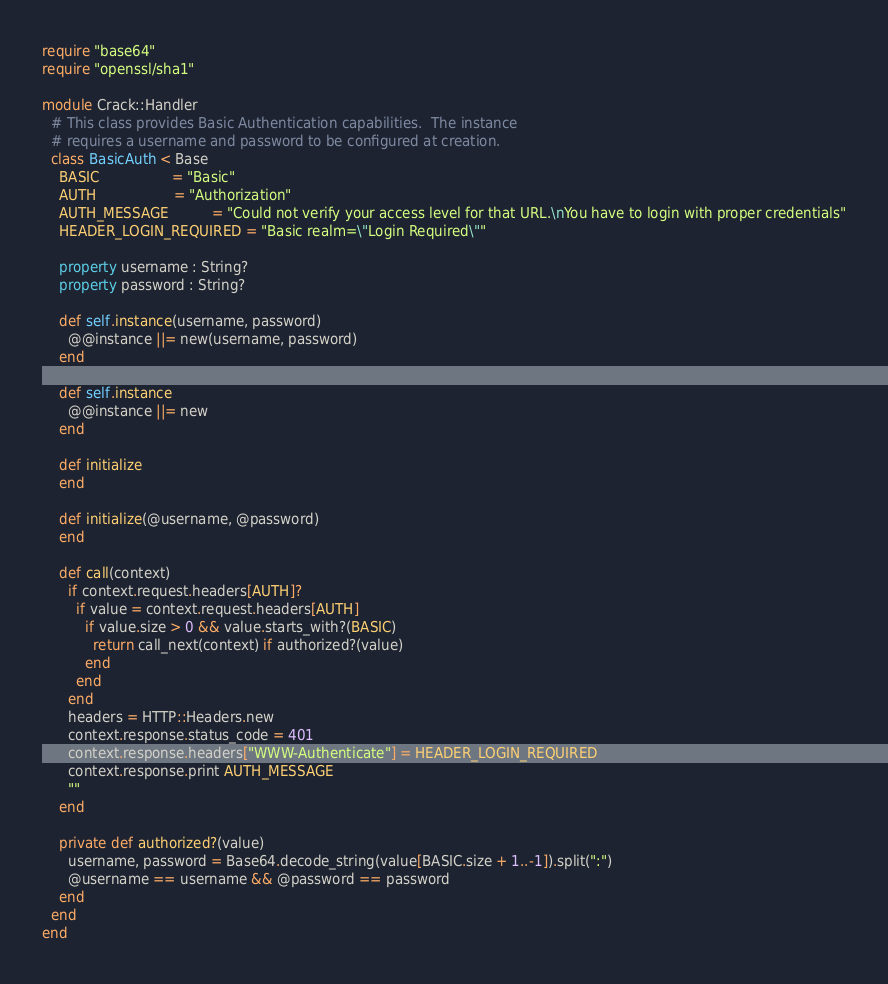Convert code to text. <code><loc_0><loc_0><loc_500><loc_500><_Crystal_>require "base64"
require "openssl/sha1"

module Crack::Handler
  # This class provides Basic Authentication capabilities.  The instance
  # requires a username and password to be configured at creation.
  class BasicAuth < Base
    BASIC                 = "Basic"
    AUTH                  = "Authorization"
    AUTH_MESSAGE          = "Could not verify your access level for that URL.\nYou have to login with proper credentials"
    HEADER_LOGIN_REQUIRED = "Basic realm=\"Login Required\""

    property username : String?
    property password : String?

    def self.instance(username, password)
      @@instance ||= new(username, password)
    end

    def self.instance
      @@instance ||= new
    end

    def initialize
    end

    def initialize(@username, @password)
    end

    def call(context)
      if context.request.headers[AUTH]?
        if value = context.request.headers[AUTH]
          if value.size > 0 && value.starts_with?(BASIC)
            return call_next(context) if authorized?(value)
          end
        end
      end
      headers = HTTP::Headers.new
      context.response.status_code = 401
      context.response.headers["WWW-Authenticate"] = HEADER_LOGIN_REQUIRED
      context.response.print AUTH_MESSAGE
      ""
    end

    private def authorized?(value)
      username, password = Base64.decode_string(value[BASIC.size + 1..-1]).split(":")
      @username == username && @password == password
    end
  end
end
</code> 